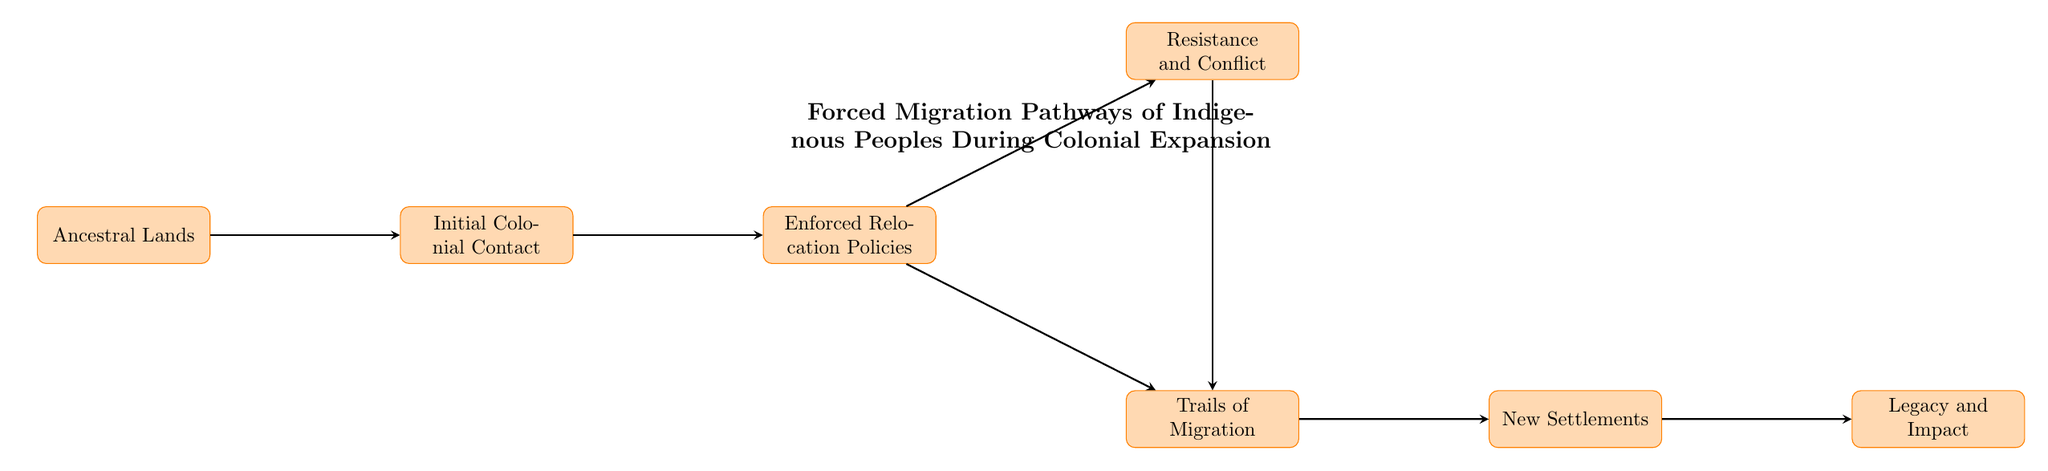What are the original homelands of indigenous groups referred to? The diagram labels node "1" as "Ancestral Lands," identifying these areas as the original homelands before colonial contact.
Answer: Ancestral Lands What node follows "Initial Colonial Contact"? According to the diagram, "Initial Colonial Contact" (node "2") connects to "Enforced Relocation Policies" (node "3").
Answer: Enforced Relocation Policies How many nodes are there in total? The diagram presents a total of seven nodes, from "Ancestral Lands" to "Legacy and Impact."
Answer: 7 What two pathways branch from "Enforced Relocation Policies"? From "Enforced Relocation Policies" (node "3"), the diagram shows two pathways leading to "Trails of Migration" (node "4") and "Resistance and Conflict" (node "5").
Answer: Trails of Migration and Resistance and Conflict Which node discusses forced migration routes? The diagram indicates that "Trails of Migration" (node "4") specifically addresses forced migration routes and notable events like the Trail of Tears.
Answer: Trails of Migration What does the last node represent? "Legacy and Impact" (node "7") represents the long-term effects on indigenous cultures, encapsulating key issues like loss of land and cultural assimilation.
Answer: Legacy and Impact How do "Resistance and Conflict" and "Trails of Migration" relate to each other? The relationships in the diagram show that "Resistance and Conflict" (node "5") can lead to "Trails of Migration" (node "4"), indicating that resistance can occur alongside or influence migration paths.
Answer: They are interconnected; resistance can lead to migration 